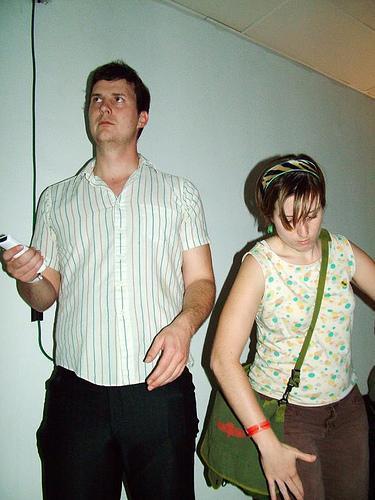How many people have wristbands on their arms?
Give a very brief answer. 1. How many shirts have stripes?
Give a very brief answer. 1. How many babies are in the house?
Give a very brief answer. 0. How many people can be seen?
Give a very brief answer. 2. 